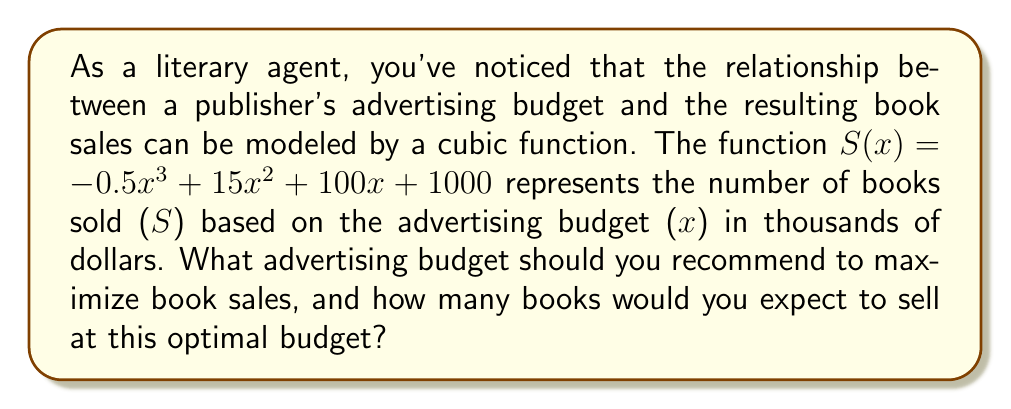Give your solution to this math problem. To find the maximum number of book sales, we need to find the local maximum of the cubic function $S(x) = -0.5x^3 + 15x^2 + 100x + 1000$. This occurs where the derivative of $S(x)$ is zero.

1) First, let's find the derivative of $S(x)$:
   $S'(x) = -1.5x^2 + 30x + 100$

2) Set $S'(x) = 0$ and solve for $x$:
   $-1.5x^2 + 30x + 100 = 0$

3) This is a quadratic equation. We can solve it using the quadratic formula:
   $x = \frac{-b \pm \sqrt{b^2 - 4ac}}{2a}$
   where $a = -1.5$, $b = 30$, and $c = 100$

4) Plugging in these values:
   $x = \frac{-30 \pm \sqrt{30^2 - 4(-1.5)(100)}}{2(-1.5)}$
   $= \frac{-30 \pm \sqrt{900 + 600}}{-3}$
   $= \frac{-30 \pm \sqrt{1500}}{-3}$
   $= \frac{-30 \pm 10\sqrt{15}}{-3}$

5) This gives us two solutions:
   $x_1 = \frac{-30 + 10\sqrt{15}}{-3} \approx 20.87$
   $x_2 = \frac{-30 - 10\sqrt{15}}{-3} \approx -0.87$

6) Since we're dealing with an advertising budget, we can discard the negative solution. Therefore, the optimal advertising budget is approximately 20.87 thousand dollars, or $20,870.

7) To find the maximum number of books sold, we plug this value back into our original function:
   $S(20.87) = -0.5(20.87)^3 + 15(20.87)^2 + 100(20.87) + 1000 \approx 5,305.48$

Therefore, we expect to sell approximately 5,305 books at this optimal advertising budget.
Answer: The optimal advertising budget is approximately $20,870, which is expected to result in sales of about 5,305 books. 